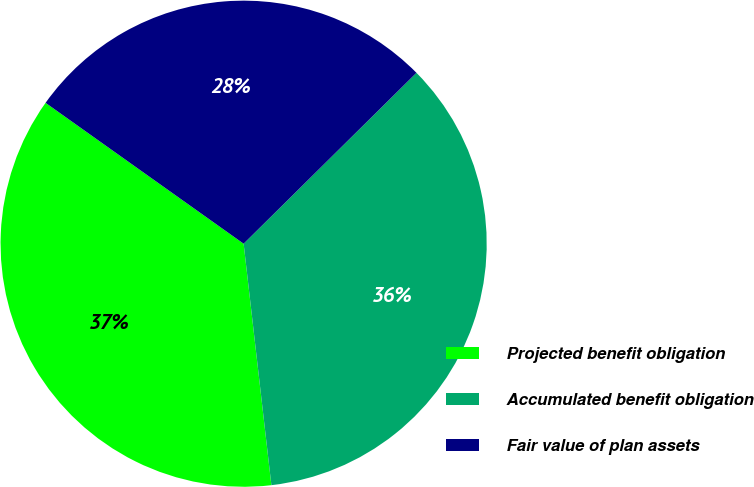Convert chart. <chart><loc_0><loc_0><loc_500><loc_500><pie_chart><fcel>Projected benefit obligation<fcel>Accumulated benefit obligation<fcel>Fair value of plan assets<nl><fcel>36.66%<fcel>35.59%<fcel>27.75%<nl></chart> 